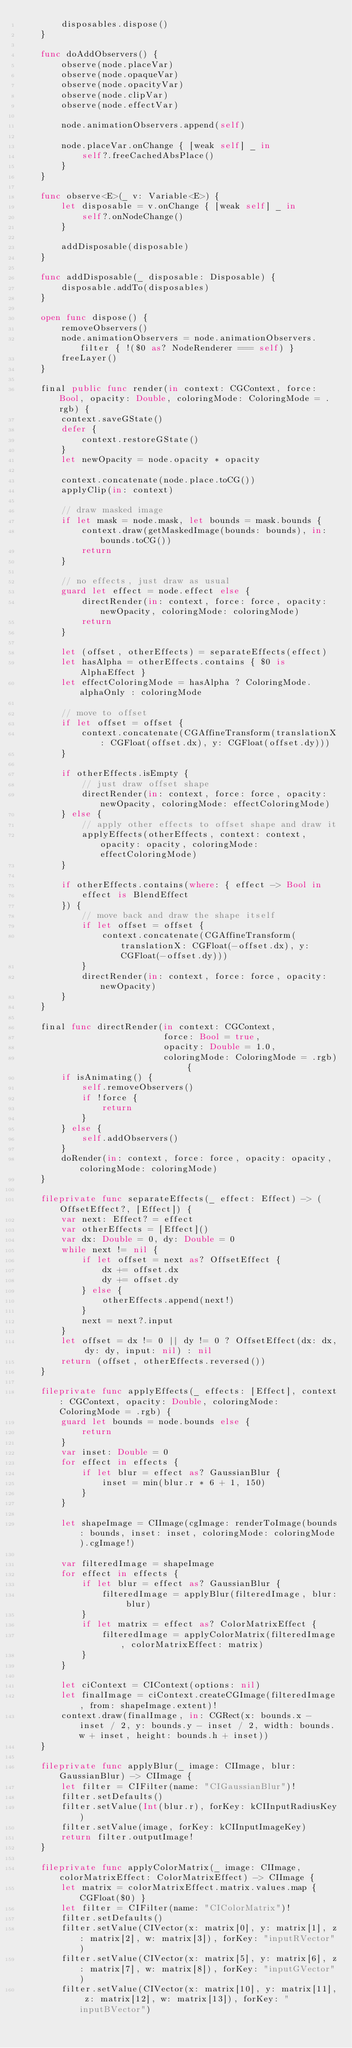<code> <loc_0><loc_0><loc_500><loc_500><_Swift_>        disposables.dispose()
    }

    func doAddObservers() {
        observe(node.placeVar)
        observe(node.opaqueVar)
        observe(node.opacityVar)
        observe(node.clipVar)
        observe(node.effectVar)

        node.animationObservers.append(self)

        node.placeVar.onChange { [weak self] _ in
            self?.freeCachedAbsPlace()
        }
    }

    func observe<E>(_ v: Variable<E>) {
        let disposable = v.onChange { [weak self] _ in
            self?.onNodeChange()
        }

        addDisposable(disposable)
    }

    func addDisposable(_ disposable: Disposable) {
        disposable.addTo(disposables)
    }

    open func dispose() {
        removeObservers()
        node.animationObservers = node.animationObservers.filter { !($0 as? NodeRenderer === self) }
        freeLayer()
    }

    final public func render(in context: CGContext, force: Bool, opacity: Double, coloringMode: ColoringMode = .rgb) {
        context.saveGState()
        defer {
            context.restoreGState()
        }
        let newOpacity = node.opacity * opacity

        context.concatenate(node.place.toCG())
        applyClip(in: context)

        // draw masked image
        if let mask = node.mask, let bounds = mask.bounds {
            context.draw(getMaskedImage(bounds: bounds), in: bounds.toCG())
            return
        }

        // no effects, just draw as usual
        guard let effect = node.effect else {
            directRender(in: context, force: force, opacity: newOpacity, coloringMode: coloringMode)
            return
        }

        let (offset, otherEffects) = separateEffects(effect)
        let hasAlpha = otherEffects.contains { $0 is AlphaEffect }
        let effectColoringMode = hasAlpha ? ColoringMode.alphaOnly : coloringMode

        // move to offset
        if let offset = offset {
            context.concatenate(CGAffineTransform(translationX: CGFloat(offset.dx), y: CGFloat(offset.dy)))
        }

        if otherEffects.isEmpty {
            // just draw offset shape
            directRender(in: context, force: force, opacity: newOpacity, coloringMode: effectColoringMode)
        } else {
            // apply other effects to offset shape and draw it
            applyEffects(otherEffects, context: context, opacity: opacity, coloringMode: effectColoringMode)
        }

        if otherEffects.contains(where: { effect -> Bool in
            effect is BlendEffect
        }) {
            // move back and draw the shape itself
            if let offset = offset {
                context.concatenate(CGAffineTransform(translationX: CGFloat(-offset.dx), y: CGFloat(-offset.dy)))
            }
            directRender(in: context, force: force, opacity: newOpacity)
        }
    }

    final func directRender(in context: CGContext,
                            force: Bool = true,
                            opacity: Double = 1.0,
                            coloringMode: ColoringMode = .rgb) {
        if isAnimating() {
            self.removeObservers()
            if !force {
                return
            }
        } else {
            self.addObservers()
        }
        doRender(in: context, force: force, opacity: opacity, coloringMode: coloringMode)
    }

    fileprivate func separateEffects(_ effect: Effect) -> (OffsetEffect?, [Effect]) {
        var next: Effect? = effect
        var otherEffects = [Effect]()
        var dx: Double = 0, dy: Double = 0
        while next != nil {
            if let offset = next as? OffsetEffect {
                dx += offset.dx
                dy += offset.dy
            } else {
                otherEffects.append(next!)
            }
            next = next?.input
        }
        let offset = dx != 0 || dy != 0 ? OffsetEffect(dx: dx, dy: dy, input: nil) : nil
        return (offset, otherEffects.reversed())
    }

    fileprivate func applyEffects(_ effects: [Effect], context: CGContext, opacity: Double, coloringMode: ColoringMode = .rgb) {
        guard let bounds = node.bounds else {
            return
        }
        var inset: Double = 0
        for effect in effects {
            if let blur = effect as? GaussianBlur {
                inset = min(blur.r * 6 + 1, 150)
            }
        }

        let shapeImage = CIImage(cgImage: renderToImage(bounds: bounds, inset: inset, coloringMode: coloringMode).cgImage!)

        var filteredImage = shapeImage
        for effect in effects {
            if let blur = effect as? GaussianBlur {
                filteredImage = applyBlur(filteredImage, blur: blur)
            }
            if let matrix = effect as? ColorMatrixEffect {
                filteredImage = applyColorMatrix(filteredImage, colorMatrixEffect: matrix)
            }
        }

        let ciContext = CIContext(options: nil)
        let finalImage = ciContext.createCGImage(filteredImage, from: shapeImage.extent)!
        context.draw(finalImage, in: CGRect(x: bounds.x - inset / 2, y: bounds.y - inset / 2, width: bounds.w + inset, height: bounds.h + inset))
    }

    fileprivate func applyBlur(_ image: CIImage, blur: GaussianBlur) -> CIImage {
        let filter = CIFilter(name: "CIGaussianBlur")!
        filter.setDefaults()
        filter.setValue(Int(blur.r), forKey: kCIInputRadiusKey)
        filter.setValue(image, forKey: kCIInputImageKey)
        return filter.outputImage!
    }

    fileprivate func applyColorMatrix(_ image: CIImage, colorMatrixEffect: ColorMatrixEffect) -> CIImage {
        let matrix = colorMatrixEffect.matrix.values.map { CGFloat($0) }
        let filter = CIFilter(name: "CIColorMatrix")!
        filter.setDefaults()
        filter.setValue(CIVector(x: matrix[0], y: matrix[1], z: matrix[2], w: matrix[3]), forKey: "inputRVector")
        filter.setValue(CIVector(x: matrix[5], y: matrix[6], z: matrix[7], w: matrix[8]), forKey: "inputGVector")
        filter.setValue(CIVector(x: matrix[10], y: matrix[11], z: matrix[12], w: matrix[13]), forKey: "inputBVector")</code> 